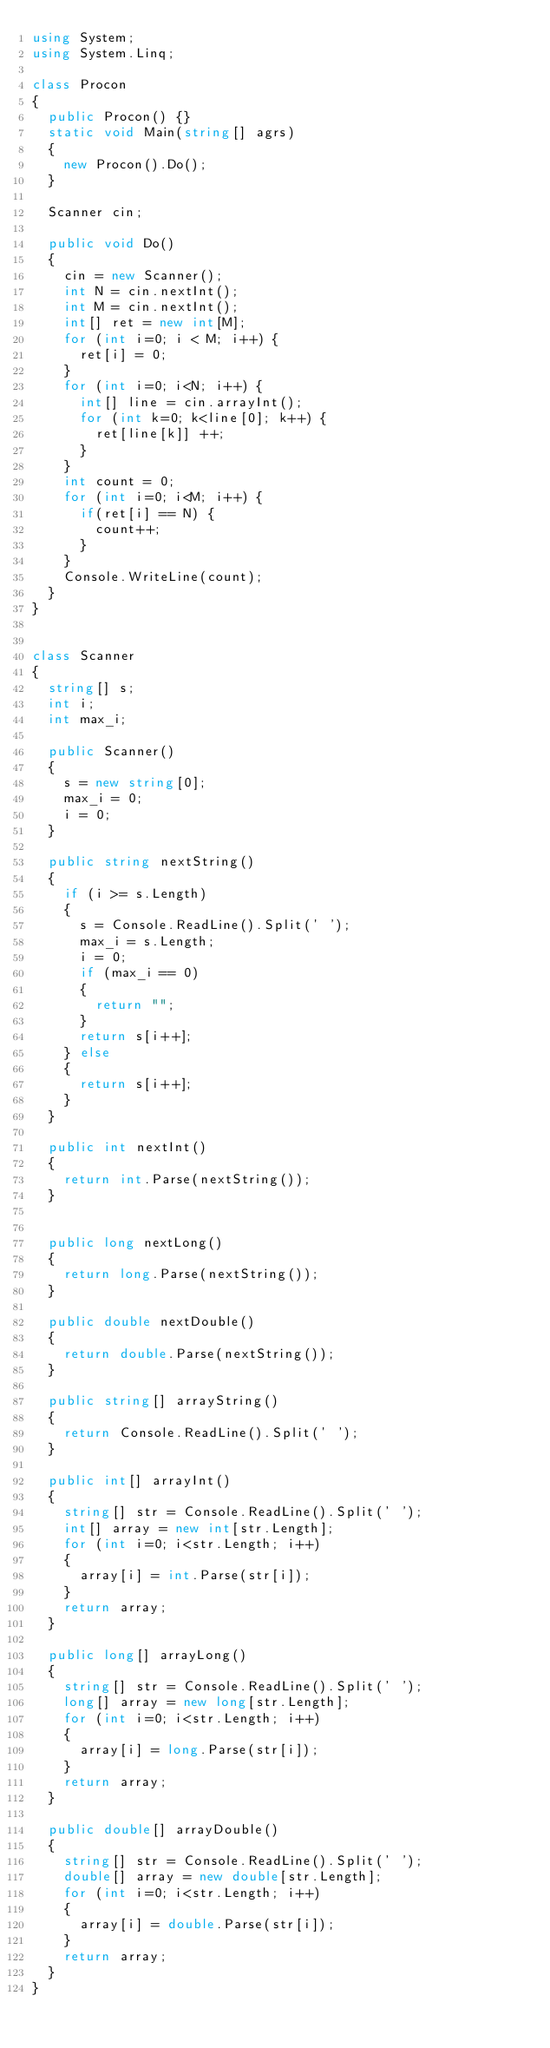<code> <loc_0><loc_0><loc_500><loc_500><_C#_>using System;
using System.Linq;

class Procon
{
  public Procon() {}
  static void Main(string[] agrs)
  {
    new Procon().Do();
  }

  Scanner cin;

  public void Do()
  {
    cin = new Scanner();
    int N = cin.nextInt();
    int M = cin.nextInt();
    int[] ret = new int[M];
    for (int i=0; i < M; i++) {
      ret[i] = 0;
    }
    for (int i=0; i<N; i++) {
      int[] line = cin.arrayInt();
      for (int k=0; k<line[0]; k++) {
        ret[line[k]] ++;
      }
    }
    int count = 0;
    for (int i=0; i<M; i++) {
      if(ret[i] == N) {
        count++;
      }
    }
    Console.WriteLine(count);
  }
}


class Scanner
{
  string[] s;
  int i;
  int max_i;

  public Scanner()
  {
    s = new string[0];
    max_i = 0;
    i = 0;
  }

  public string nextString()
  {
    if (i >= s.Length) 
    {
      s = Console.ReadLine().Split(' ');
      max_i = s.Length;
      i = 0;
      if (max_i == 0) 
      {
        return "";
      }
      return s[i++];
    } else 
    {
      return s[i++];
    }
  }

  public int nextInt()
  {
    return int.Parse(nextString());
  }


  public long nextLong()
  {
    return long.Parse(nextString());
  }

  public double nextDouble()
  {
    return double.Parse(nextString());
  }

  public string[] arrayString()
  {
    return Console.ReadLine().Split(' ');
  }

  public int[] arrayInt()
  {
    string[] str = Console.ReadLine().Split(' ');
    int[] array = new int[str.Length];
    for (int i=0; i<str.Length; i++) 
    {
      array[i] = int.Parse(str[i]);
    }
    return array;
  }

  public long[] arrayLong()
  {
    string[] str = Console.ReadLine().Split(' ');
    long[] array = new long[str.Length];
    for (int i=0; i<str.Length; i++) 
    {
      array[i] = long.Parse(str[i]);
    }
    return array;
  }

  public double[] arrayDouble()
  {
    string[] str = Console.ReadLine().Split(' ');
    double[] array = new double[str.Length];
    for (int i=0; i<str.Length; i++) 
    {
      array[i] = double.Parse(str[i]);
    }
    return array;
  }
}
</code> 